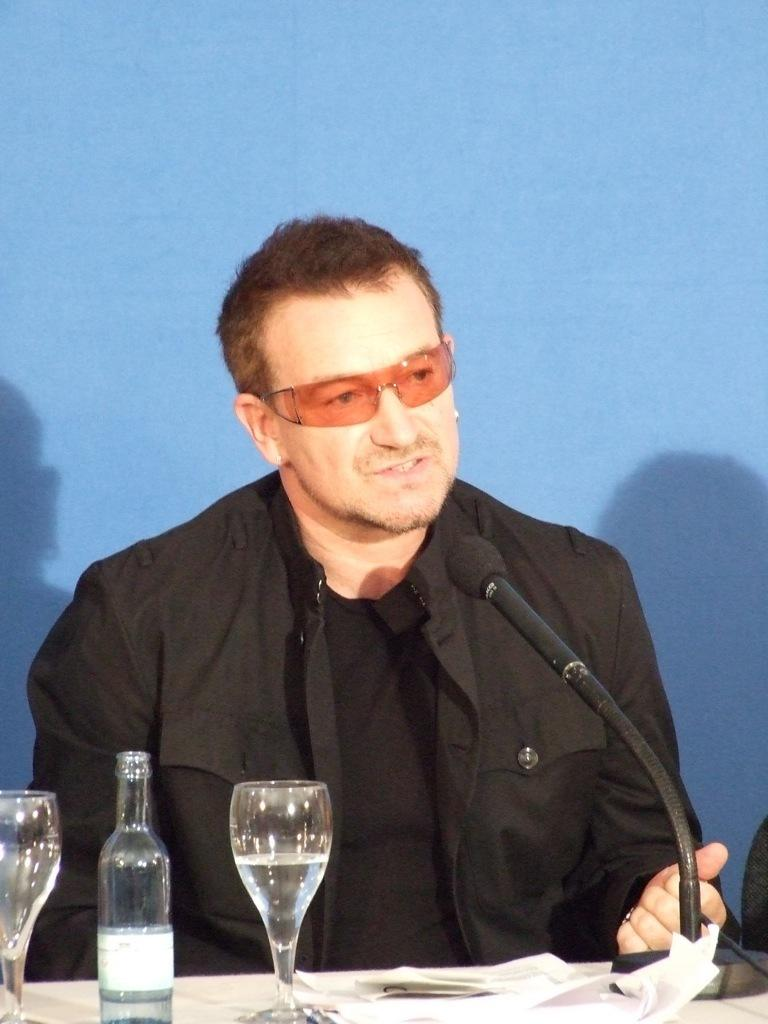Who is the person in the image? There is a man in the image. What is the man doing in the image? The man is sitting on a chair and speaking into a microphone. Where is the microphone located in the image? The microphone is on a table. What items related to hydration can be seen in the image? There is a bottle and a glass of water in the image. What type of wax is being used to create the man's sculpture in the image? There is no sculpture or wax present in the image; it features a man sitting on a chair and speaking into a microphone. What direction is the man looking in the image? The image does not provide information about the direction the man is looking, as it only shows him sitting on a chair and speaking into a microphone. 